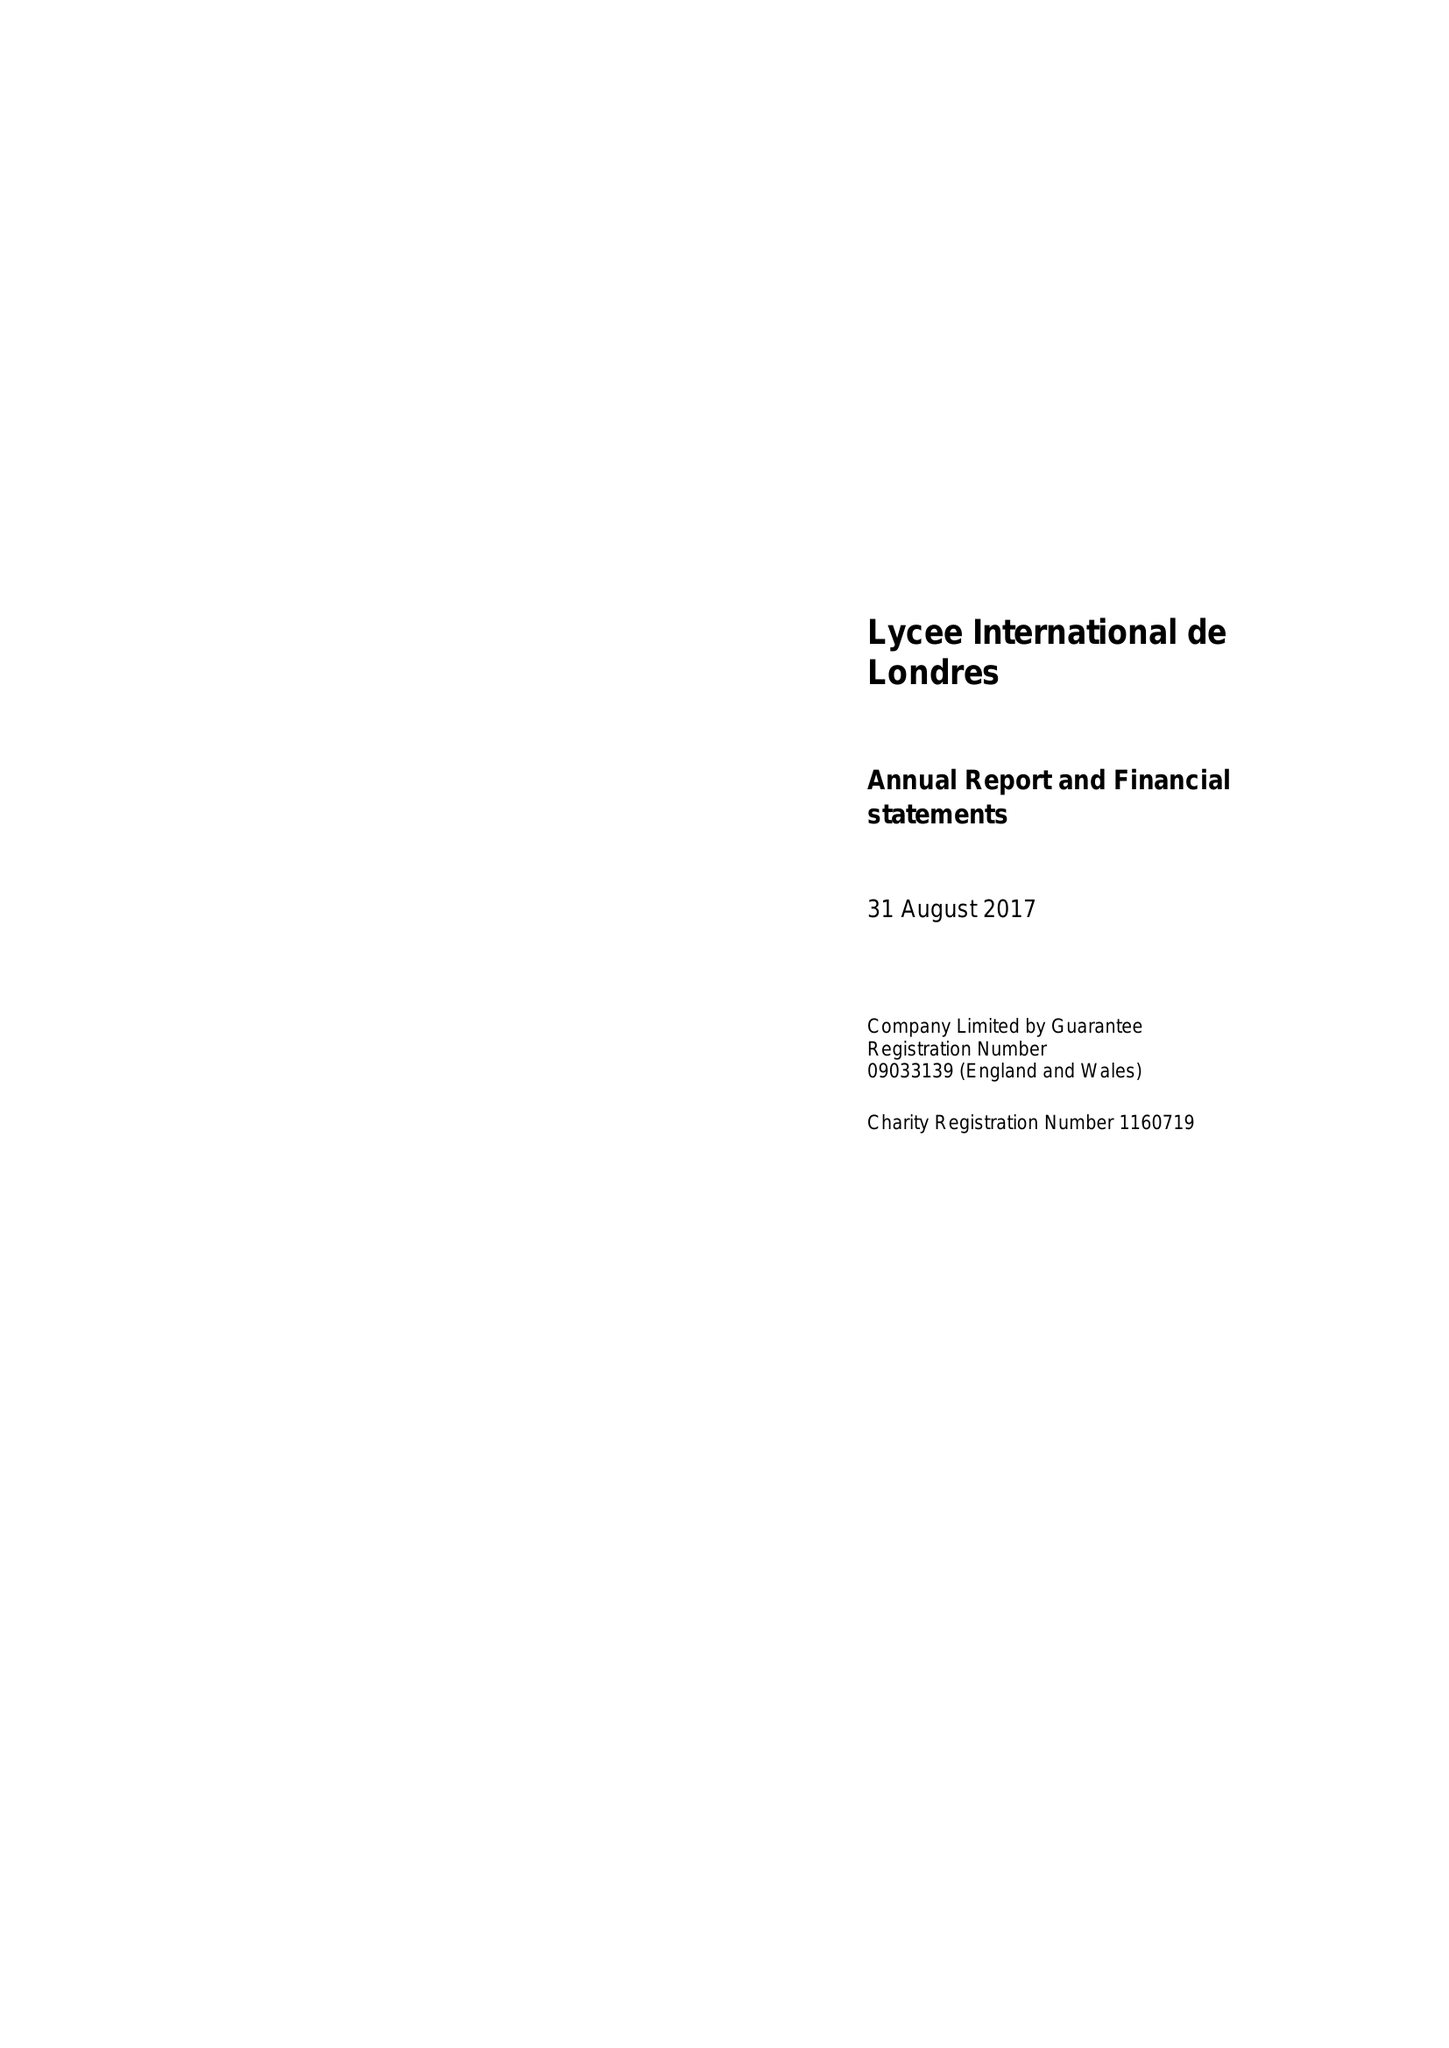What is the value for the address__street_line?
Answer the question using a single word or phrase. 54 FORTY LANE 